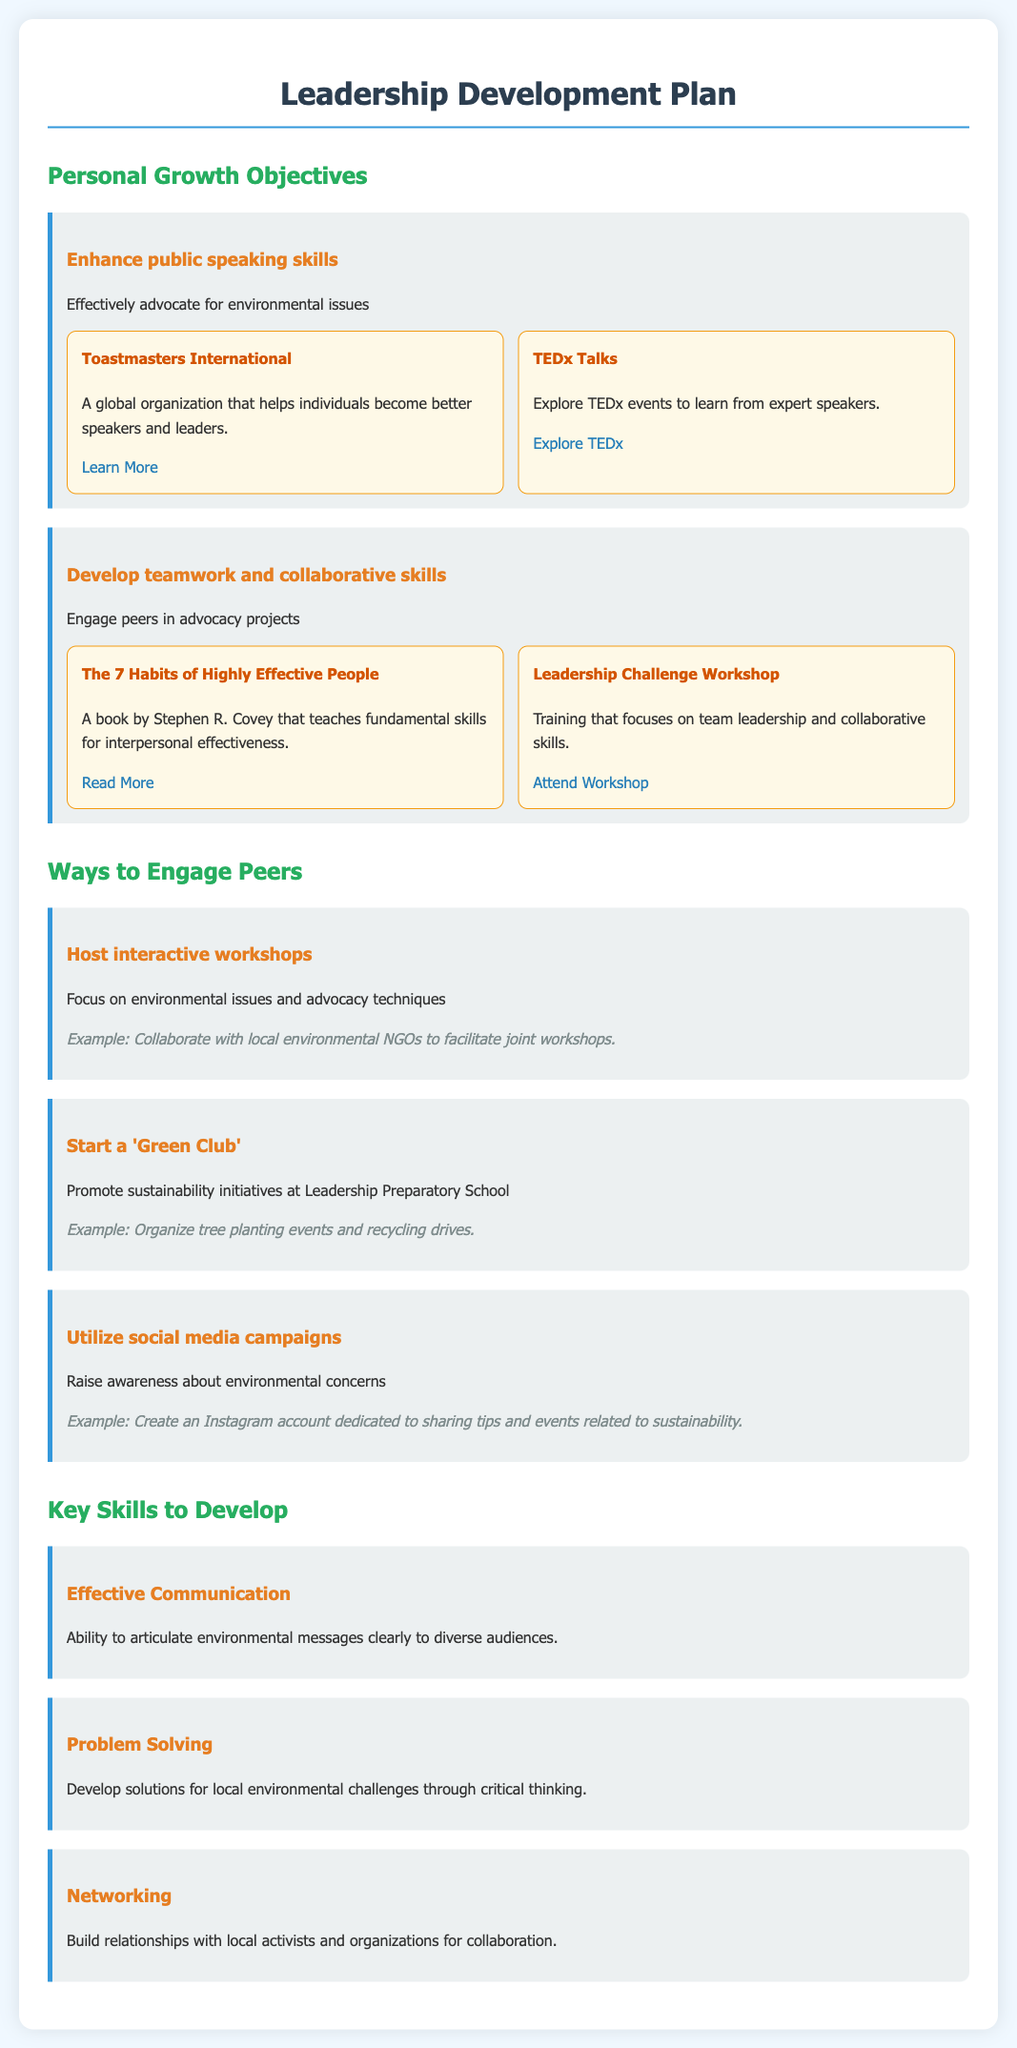What are the two main personal growth objectives listed? The document outlines specific objectives for personal growth, which are enhancing public speaking skills and developing teamwork and collaborative skills.
Answer: Enhance public speaking skills, Develop teamwork and collaborative skills How many resources are listed for improving public speaking skills? The section on enhancing public speaking skills includes two resources: Toastmasters International and TEDx Talks.
Answer: 2 What is the title of the book recommended for developing teamwork skills? The Leadership Development Plan mentions "The 7 Habits of Highly Effective People" as a resource for improving teamwork and collaborative skills.
Answer: The 7 Habits of Highly Effective People Name one way to engage peers in environmental advocacy. The document specifies several strategies, including hosting interactive workshops, starting a 'Green Club', and utilizing social media campaigns.
Answer: Host interactive workshops What skill focuses on building relationships with local activists? Networking is the key skill mentioned that focuses on building relationships for collaboration with local activists and organizations.
Answer: Networking What type of organization is Toastmasters International? The document describes Toastmasters International as a global organization helping individuals become better speakers and leaders.
Answer: Global organization How is effective communication defined in the document? The document defines effective communication as the ability to articulate environmental messages clearly to diverse audiences.
Answer: Ability to articulate environmental messages clearly What is one example given for starting a 'Green Club'? The document provides an example of organizing tree planting events as an initiative for starting a 'Green Club'.
Answer: Organize tree planting events 